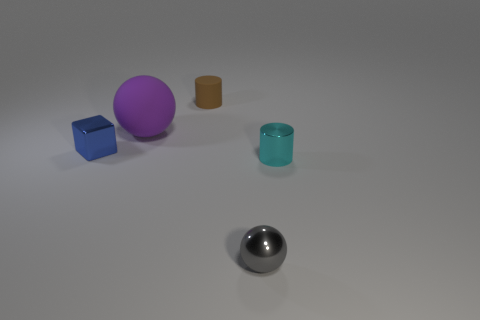What is the size of the rubber object that is in front of the small cylinder that is behind the tiny metal cube?
Offer a terse response. Large. Are there the same number of rubber things behind the blue metal thing and tiny blue blocks that are to the right of the big purple thing?
Provide a short and direct response. No. Is there a big object that is behind the cylinder on the left side of the tiny metal cylinder?
Your answer should be very brief. No. What number of objects are in front of the tiny shiny object that is on the right side of the gray thing in front of the tiny metallic cube?
Give a very brief answer. 1. Are there fewer gray spheres than tiny things?
Your answer should be compact. Yes. There is a small object behind the purple ball; is its shape the same as the tiny metal object that is to the right of the small gray ball?
Your response must be concise. Yes. What is the color of the tiny matte cylinder?
Keep it short and to the point. Brown. What number of shiny things are either cyan cylinders or small yellow cubes?
Ensure brevity in your answer.  1. What is the color of the other thing that is the same shape as the big purple rubber thing?
Keep it short and to the point. Gray. Is there a big green metallic ball?
Keep it short and to the point. No. 